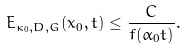Convert formula to latex. <formula><loc_0><loc_0><loc_500><loc_500>E _ { \kappa _ { 0 } , D , G } ( x _ { 0 } , t ) \leq \frac { C } { f ( \alpha _ { 0 } t ) } .</formula> 